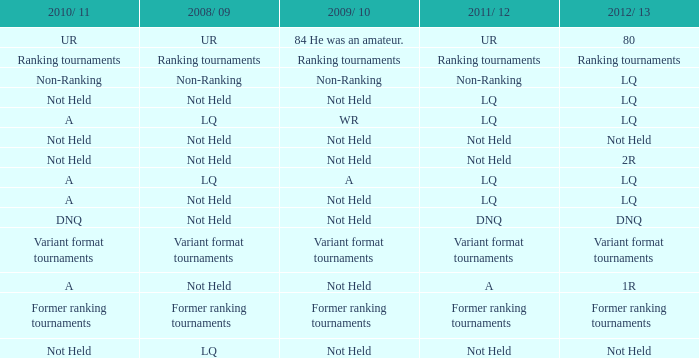What 2010/ 11 has not held as 2009/ 10, and 1r as the 2012/ 13? A. 